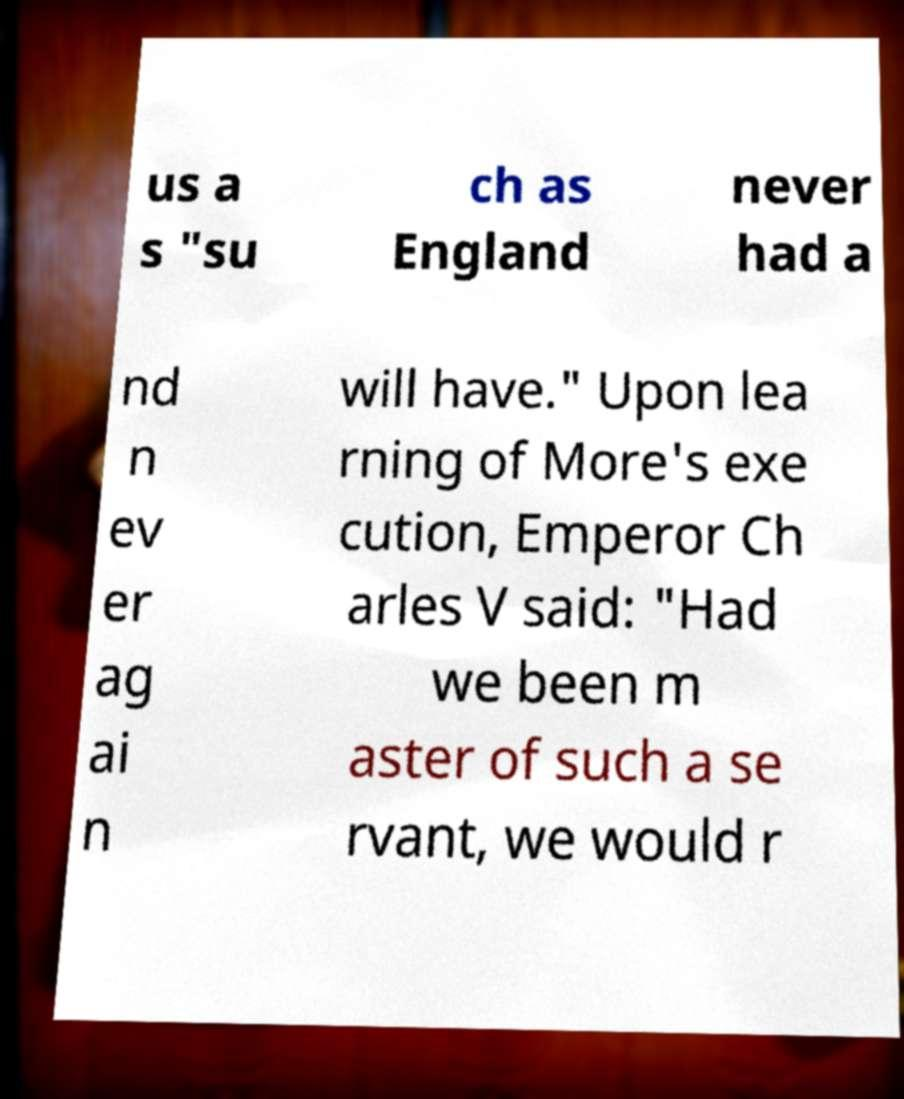Please identify and transcribe the text found in this image. us a s "su ch as England never had a nd n ev er ag ai n will have." Upon lea rning of More's exe cution, Emperor Ch arles V said: "Had we been m aster of such a se rvant, we would r 